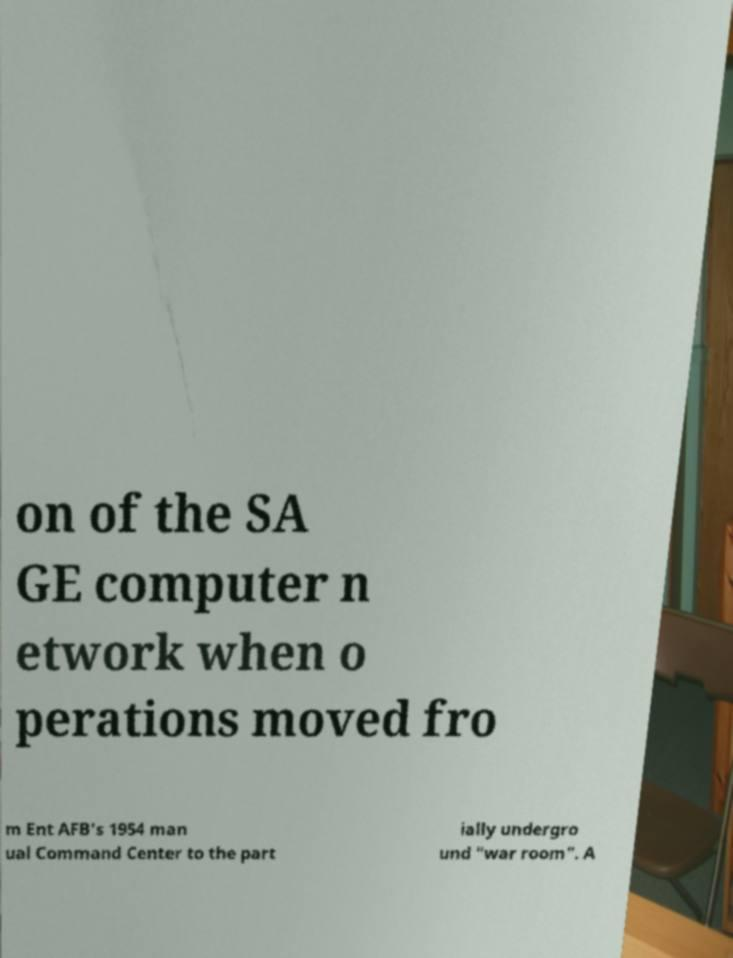Could you extract and type out the text from this image? on of the SA GE computer n etwork when o perations moved fro m Ent AFB's 1954 man ual Command Center to the part ially undergro und "war room". A 